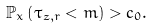Convert formula to latex. <formula><loc_0><loc_0><loc_500><loc_500>\mathbb { P } _ { x } \left ( \tau _ { z , r } < m \right ) > c _ { 0 } .</formula> 